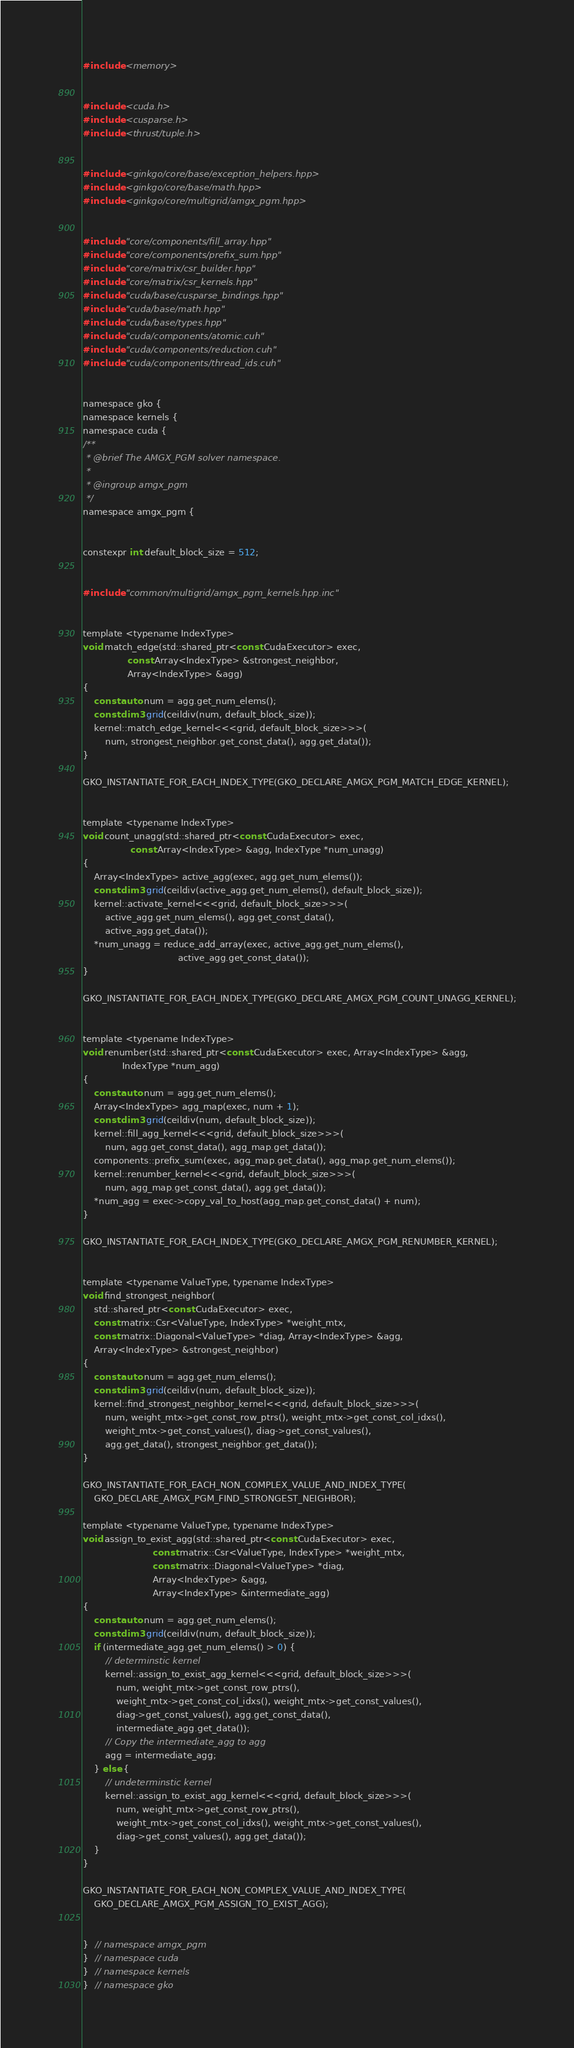Convert code to text. <code><loc_0><loc_0><loc_500><loc_500><_Cuda_>
#include <memory>


#include <cuda.h>
#include <cusparse.h>
#include <thrust/tuple.h>


#include <ginkgo/core/base/exception_helpers.hpp>
#include <ginkgo/core/base/math.hpp>
#include <ginkgo/core/multigrid/amgx_pgm.hpp>


#include "core/components/fill_array.hpp"
#include "core/components/prefix_sum.hpp"
#include "core/matrix/csr_builder.hpp"
#include "core/matrix/csr_kernels.hpp"
#include "cuda/base/cusparse_bindings.hpp"
#include "cuda/base/math.hpp"
#include "cuda/base/types.hpp"
#include "cuda/components/atomic.cuh"
#include "cuda/components/reduction.cuh"
#include "cuda/components/thread_ids.cuh"


namespace gko {
namespace kernels {
namespace cuda {
/**
 * @brief The AMGX_PGM solver namespace.
 *
 * @ingroup amgx_pgm
 */
namespace amgx_pgm {


constexpr int default_block_size = 512;


#include "common/multigrid/amgx_pgm_kernels.hpp.inc"


template <typename IndexType>
void match_edge(std::shared_ptr<const CudaExecutor> exec,
                const Array<IndexType> &strongest_neighbor,
                Array<IndexType> &agg)
{
    const auto num = agg.get_num_elems();
    const dim3 grid(ceildiv(num, default_block_size));
    kernel::match_edge_kernel<<<grid, default_block_size>>>(
        num, strongest_neighbor.get_const_data(), agg.get_data());
}

GKO_INSTANTIATE_FOR_EACH_INDEX_TYPE(GKO_DECLARE_AMGX_PGM_MATCH_EDGE_KERNEL);


template <typename IndexType>
void count_unagg(std::shared_ptr<const CudaExecutor> exec,
                 const Array<IndexType> &agg, IndexType *num_unagg)
{
    Array<IndexType> active_agg(exec, agg.get_num_elems());
    const dim3 grid(ceildiv(active_agg.get_num_elems(), default_block_size));
    kernel::activate_kernel<<<grid, default_block_size>>>(
        active_agg.get_num_elems(), agg.get_const_data(),
        active_agg.get_data());
    *num_unagg = reduce_add_array(exec, active_agg.get_num_elems(),
                                  active_agg.get_const_data());
}

GKO_INSTANTIATE_FOR_EACH_INDEX_TYPE(GKO_DECLARE_AMGX_PGM_COUNT_UNAGG_KERNEL);


template <typename IndexType>
void renumber(std::shared_ptr<const CudaExecutor> exec, Array<IndexType> &agg,
              IndexType *num_agg)
{
    const auto num = agg.get_num_elems();
    Array<IndexType> agg_map(exec, num + 1);
    const dim3 grid(ceildiv(num, default_block_size));
    kernel::fill_agg_kernel<<<grid, default_block_size>>>(
        num, agg.get_const_data(), agg_map.get_data());
    components::prefix_sum(exec, agg_map.get_data(), agg_map.get_num_elems());
    kernel::renumber_kernel<<<grid, default_block_size>>>(
        num, agg_map.get_const_data(), agg.get_data());
    *num_agg = exec->copy_val_to_host(agg_map.get_const_data() + num);
}

GKO_INSTANTIATE_FOR_EACH_INDEX_TYPE(GKO_DECLARE_AMGX_PGM_RENUMBER_KERNEL);


template <typename ValueType, typename IndexType>
void find_strongest_neighbor(
    std::shared_ptr<const CudaExecutor> exec,
    const matrix::Csr<ValueType, IndexType> *weight_mtx,
    const matrix::Diagonal<ValueType> *diag, Array<IndexType> &agg,
    Array<IndexType> &strongest_neighbor)
{
    const auto num = agg.get_num_elems();
    const dim3 grid(ceildiv(num, default_block_size));
    kernel::find_strongest_neighbor_kernel<<<grid, default_block_size>>>(
        num, weight_mtx->get_const_row_ptrs(), weight_mtx->get_const_col_idxs(),
        weight_mtx->get_const_values(), diag->get_const_values(),
        agg.get_data(), strongest_neighbor.get_data());
}

GKO_INSTANTIATE_FOR_EACH_NON_COMPLEX_VALUE_AND_INDEX_TYPE(
    GKO_DECLARE_AMGX_PGM_FIND_STRONGEST_NEIGHBOR);

template <typename ValueType, typename IndexType>
void assign_to_exist_agg(std::shared_ptr<const CudaExecutor> exec,
                         const matrix::Csr<ValueType, IndexType> *weight_mtx,
                         const matrix::Diagonal<ValueType> *diag,
                         Array<IndexType> &agg,
                         Array<IndexType> &intermediate_agg)
{
    const auto num = agg.get_num_elems();
    const dim3 grid(ceildiv(num, default_block_size));
    if (intermediate_agg.get_num_elems() > 0) {
        // determinstic kernel
        kernel::assign_to_exist_agg_kernel<<<grid, default_block_size>>>(
            num, weight_mtx->get_const_row_ptrs(),
            weight_mtx->get_const_col_idxs(), weight_mtx->get_const_values(),
            diag->get_const_values(), agg.get_const_data(),
            intermediate_agg.get_data());
        // Copy the intermediate_agg to agg
        agg = intermediate_agg;
    } else {
        // undeterminstic kernel
        kernel::assign_to_exist_agg_kernel<<<grid, default_block_size>>>(
            num, weight_mtx->get_const_row_ptrs(),
            weight_mtx->get_const_col_idxs(), weight_mtx->get_const_values(),
            diag->get_const_values(), agg.get_data());
    }
}

GKO_INSTANTIATE_FOR_EACH_NON_COMPLEX_VALUE_AND_INDEX_TYPE(
    GKO_DECLARE_AMGX_PGM_ASSIGN_TO_EXIST_AGG);


}  // namespace amgx_pgm
}  // namespace cuda
}  // namespace kernels
}  // namespace gko
</code> 